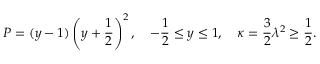<formula> <loc_0><loc_0><loc_500><loc_500>P = ( y - 1 ) \left ( y + \frac { 1 } { 2 } \right ) ^ { 2 } , \quad - \frac { 1 } { 2 } \leq y \leq 1 , \quad \kappa = \frac { 3 } { 2 } \lambda ^ { 2 } \geq \frac { 1 } { 2 } .</formula> 